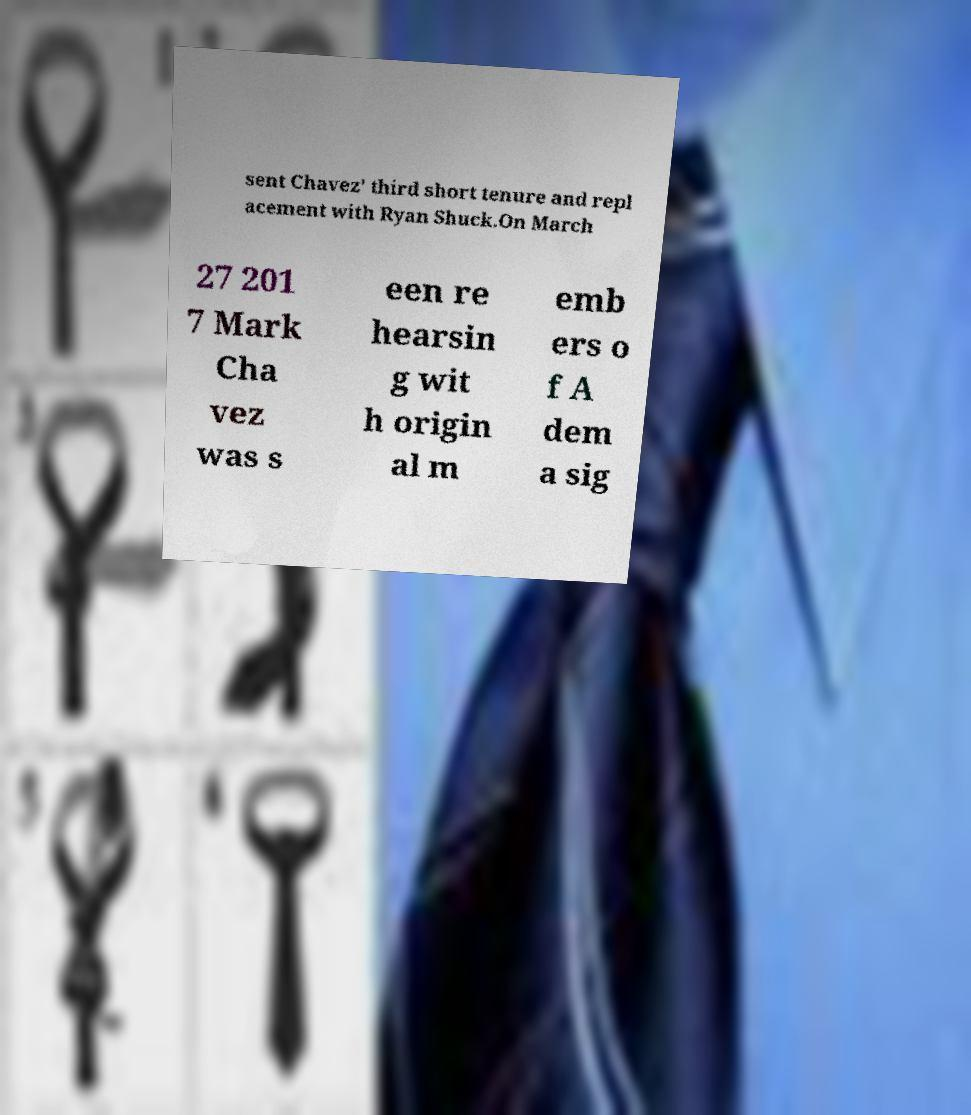Can you accurately transcribe the text from the provided image for me? sent Chavez' third short tenure and repl acement with Ryan Shuck.On March 27 201 7 Mark Cha vez was s een re hearsin g wit h origin al m emb ers o f A dem a sig 